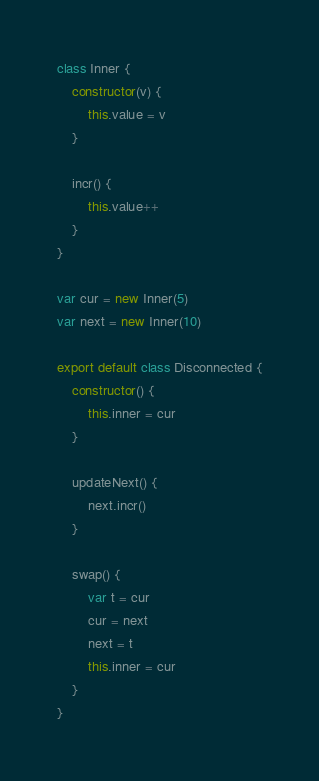<code> <loc_0><loc_0><loc_500><loc_500><_JavaScript_>class Inner {
	constructor(v) {
		this.value = v
	}

	incr() {
		this.value++
	}
}

var cur = new Inner(5)
var next = new Inner(10)

export default class Disconnected {
	constructor() {
		this.inner = cur
	}

	updateNext() {
		next.incr()
	}

	swap() {
		var t = cur
		cur = next
		next = t
		this.inner = cur
	}
}</code> 